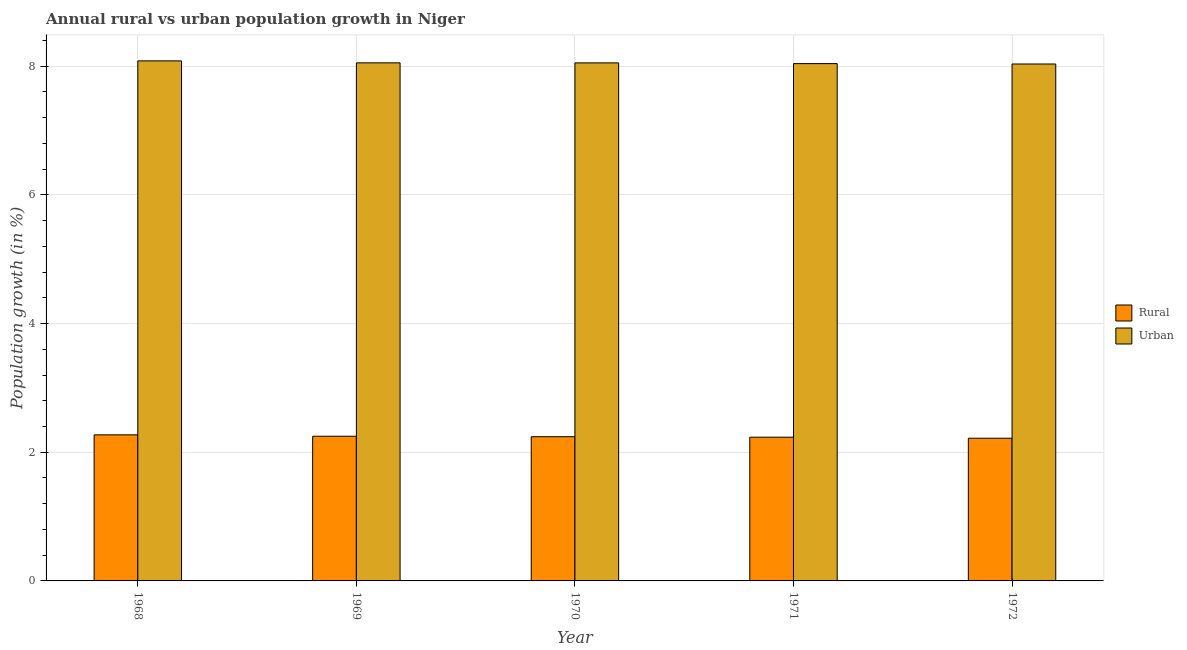How many different coloured bars are there?
Offer a very short reply. 2. How many groups of bars are there?
Provide a succinct answer. 5. Are the number of bars on each tick of the X-axis equal?
Keep it short and to the point. Yes. How many bars are there on the 4th tick from the left?
Give a very brief answer. 2. How many bars are there on the 4th tick from the right?
Ensure brevity in your answer.  2. What is the urban population growth in 1969?
Provide a succinct answer. 8.05. Across all years, what is the maximum urban population growth?
Provide a short and direct response. 8.08. Across all years, what is the minimum urban population growth?
Keep it short and to the point. 8.03. In which year was the rural population growth maximum?
Keep it short and to the point. 1968. In which year was the urban population growth minimum?
Your answer should be very brief. 1972. What is the total rural population growth in the graph?
Keep it short and to the point. 11.21. What is the difference between the urban population growth in 1971 and that in 1972?
Give a very brief answer. 0.01. What is the difference between the rural population growth in 1971 and the urban population growth in 1972?
Your answer should be very brief. 0.02. What is the average urban population growth per year?
Ensure brevity in your answer.  8.05. What is the ratio of the rural population growth in 1968 to that in 1969?
Provide a short and direct response. 1.01. Is the rural population growth in 1968 less than that in 1972?
Provide a short and direct response. No. Is the difference between the rural population growth in 1968 and 1969 greater than the difference between the urban population growth in 1968 and 1969?
Provide a succinct answer. No. What is the difference between the highest and the second highest urban population growth?
Make the answer very short. 0.03. What is the difference between the highest and the lowest urban population growth?
Ensure brevity in your answer.  0.05. In how many years, is the urban population growth greater than the average urban population growth taken over all years?
Your response must be concise. 1. Is the sum of the rural population growth in 1971 and 1972 greater than the maximum urban population growth across all years?
Make the answer very short. Yes. What does the 1st bar from the left in 1971 represents?
Provide a short and direct response. Rural. What does the 2nd bar from the right in 1971 represents?
Make the answer very short. Rural. How many bars are there?
Keep it short and to the point. 10. Are all the bars in the graph horizontal?
Your response must be concise. No. Does the graph contain any zero values?
Provide a succinct answer. No. Does the graph contain grids?
Give a very brief answer. Yes. Where does the legend appear in the graph?
Your answer should be very brief. Center right. How many legend labels are there?
Your answer should be very brief. 2. What is the title of the graph?
Your response must be concise. Annual rural vs urban population growth in Niger. Does "Urban agglomerations" appear as one of the legend labels in the graph?
Your answer should be compact. No. What is the label or title of the X-axis?
Ensure brevity in your answer.  Year. What is the label or title of the Y-axis?
Give a very brief answer. Population growth (in %). What is the Population growth (in %) in Rural in 1968?
Offer a very short reply. 2.27. What is the Population growth (in %) in Urban  in 1968?
Provide a short and direct response. 8.08. What is the Population growth (in %) of Rural in 1969?
Give a very brief answer. 2.25. What is the Population growth (in %) in Urban  in 1969?
Offer a terse response. 8.05. What is the Population growth (in %) of Rural in 1970?
Ensure brevity in your answer.  2.24. What is the Population growth (in %) of Urban  in 1970?
Keep it short and to the point. 8.05. What is the Population growth (in %) in Rural in 1971?
Provide a succinct answer. 2.23. What is the Population growth (in %) of Urban  in 1971?
Your answer should be very brief. 8.04. What is the Population growth (in %) in Rural in 1972?
Provide a succinct answer. 2.22. What is the Population growth (in %) of Urban  in 1972?
Offer a very short reply. 8.03. Across all years, what is the maximum Population growth (in %) in Rural?
Your response must be concise. 2.27. Across all years, what is the maximum Population growth (in %) in Urban ?
Offer a terse response. 8.08. Across all years, what is the minimum Population growth (in %) in Rural?
Make the answer very short. 2.22. Across all years, what is the minimum Population growth (in %) in Urban ?
Your answer should be compact. 8.03. What is the total Population growth (in %) of Rural in the graph?
Make the answer very short. 11.21. What is the total Population growth (in %) of Urban  in the graph?
Your answer should be compact. 40.26. What is the difference between the Population growth (in %) in Rural in 1968 and that in 1969?
Provide a succinct answer. 0.02. What is the difference between the Population growth (in %) in Urban  in 1968 and that in 1969?
Keep it short and to the point. 0.03. What is the difference between the Population growth (in %) in Rural in 1968 and that in 1970?
Offer a very short reply. 0.03. What is the difference between the Population growth (in %) of Urban  in 1968 and that in 1970?
Make the answer very short. 0.03. What is the difference between the Population growth (in %) of Rural in 1968 and that in 1971?
Keep it short and to the point. 0.04. What is the difference between the Population growth (in %) in Urban  in 1968 and that in 1971?
Provide a succinct answer. 0.04. What is the difference between the Population growth (in %) of Rural in 1968 and that in 1972?
Offer a terse response. 0.05. What is the difference between the Population growth (in %) in Urban  in 1968 and that in 1972?
Offer a terse response. 0.05. What is the difference between the Population growth (in %) in Rural in 1969 and that in 1970?
Your answer should be compact. 0.01. What is the difference between the Population growth (in %) in Urban  in 1969 and that in 1970?
Offer a terse response. 0. What is the difference between the Population growth (in %) in Rural in 1969 and that in 1971?
Offer a terse response. 0.02. What is the difference between the Population growth (in %) of Urban  in 1969 and that in 1971?
Offer a very short reply. 0.01. What is the difference between the Population growth (in %) in Rural in 1969 and that in 1972?
Your answer should be compact. 0.03. What is the difference between the Population growth (in %) in Urban  in 1969 and that in 1972?
Your answer should be compact. 0.02. What is the difference between the Population growth (in %) of Rural in 1970 and that in 1971?
Provide a short and direct response. 0.01. What is the difference between the Population growth (in %) in Urban  in 1970 and that in 1971?
Your response must be concise. 0.01. What is the difference between the Population growth (in %) in Rural in 1970 and that in 1972?
Give a very brief answer. 0.02. What is the difference between the Population growth (in %) of Urban  in 1970 and that in 1972?
Your answer should be compact. 0.02. What is the difference between the Population growth (in %) in Rural in 1971 and that in 1972?
Provide a succinct answer. 0.02. What is the difference between the Population growth (in %) of Urban  in 1971 and that in 1972?
Your answer should be compact. 0.01. What is the difference between the Population growth (in %) of Rural in 1968 and the Population growth (in %) of Urban  in 1969?
Keep it short and to the point. -5.78. What is the difference between the Population growth (in %) of Rural in 1968 and the Population growth (in %) of Urban  in 1970?
Keep it short and to the point. -5.78. What is the difference between the Population growth (in %) in Rural in 1968 and the Population growth (in %) in Urban  in 1971?
Provide a short and direct response. -5.77. What is the difference between the Population growth (in %) in Rural in 1968 and the Population growth (in %) in Urban  in 1972?
Your response must be concise. -5.76. What is the difference between the Population growth (in %) in Rural in 1969 and the Population growth (in %) in Urban  in 1970?
Your response must be concise. -5.8. What is the difference between the Population growth (in %) in Rural in 1969 and the Population growth (in %) in Urban  in 1971?
Give a very brief answer. -5.79. What is the difference between the Population growth (in %) of Rural in 1969 and the Population growth (in %) of Urban  in 1972?
Provide a succinct answer. -5.79. What is the difference between the Population growth (in %) of Rural in 1970 and the Population growth (in %) of Urban  in 1971?
Give a very brief answer. -5.8. What is the difference between the Population growth (in %) of Rural in 1970 and the Population growth (in %) of Urban  in 1972?
Your answer should be compact. -5.79. What is the difference between the Population growth (in %) of Rural in 1971 and the Population growth (in %) of Urban  in 1972?
Give a very brief answer. -5.8. What is the average Population growth (in %) in Rural per year?
Keep it short and to the point. 2.24. What is the average Population growth (in %) in Urban  per year?
Your response must be concise. 8.05. In the year 1968, what is the difference between the Population growth (in %) of Rural and Population growth (in %) of Urban ?
Offer a terse response. -5.81. In the year 1969, what is the difference between the Population growth (in %) in Rural and Population growth (in %) in Urban ?
Provide a succinct answer. -5.8. In the year 1970, what is the difference between the Population growth (in %) of Rural and Population growth (in %) of Urban ?
Your answer should be compact. -5.81. In the year 1971, what is the difference between the Population growth (in %) of Rural and Population growth (in %) of Urban ?
Offer a very short reply. -5.81. In the year 1972, what is the difference between the Population growth (in %) of Rural and Population growth (in %) of Urban ?
Your response must be concise. -5.82. What is the ratio of the Population growth (in %) in Rural in 1968 to that in 1969?
Provide a succinct answer. 1.01. What is the ratio of the Population growth (in %) of Rural in 1968 to that in 1970?
Make the answer very short. 1.01. What is the ratio of the Population growth (in %) of Rural in 1968 to that in 1971?
Provide a succinct answer. 1.02. What is the ratio of the Population growth (in %) in Rural in 1968 to that in 1972?
Provide a succinct answer. 1.02. What is the ratio of the Population growth (in %) of Urban  in 1968 to that in 1972?
Your response must be concise. 1.01. What is the ratio of the Population growth (in %) of Urban  in 1969 to that in 1970?
Offer a terse response. 1. What is the ratio of the Population growth (in %) of Rural in 1969 to that in 1971?
Provide a short and direct response. 1.01. What is the ratio of the Population growth (in %) in Urban  in 1969 to that in 1971?
Offer a very short reply. 1. What is the ratio of the Population growth (in %) of Rural in 1969 to that in 1972?
Offer a very short reply. 1.01. What is the ratio of the Population growth (in %) in Rural in 1970 to that in 1971?
Provide a succinct answer. 1. What is the ratio of the Population growth (in %) of Rural in 1970 to that in 1972?
Your answer should be compact. 1.01. What is the ratio of the Population growth (in %) of Rural in 1971 to that in 1972?
Offer a terse response. 1.01. What is the difference between the highest and the second highest Population growth (in %) of Rural?
Make the answer very short. 0.02. What is the difference between the highest and the second highest Population growth (in %) of Urban ?
Provide a succinct answer. 0.03. What is the difference between the highest and the lowest Population growth (in %) of Rural?
Your answer should be very brief. 0.05. What is the difference between the highest and the lowest Population growth (in %) of Urban ?
Your answer should be very brief. 0.05. 